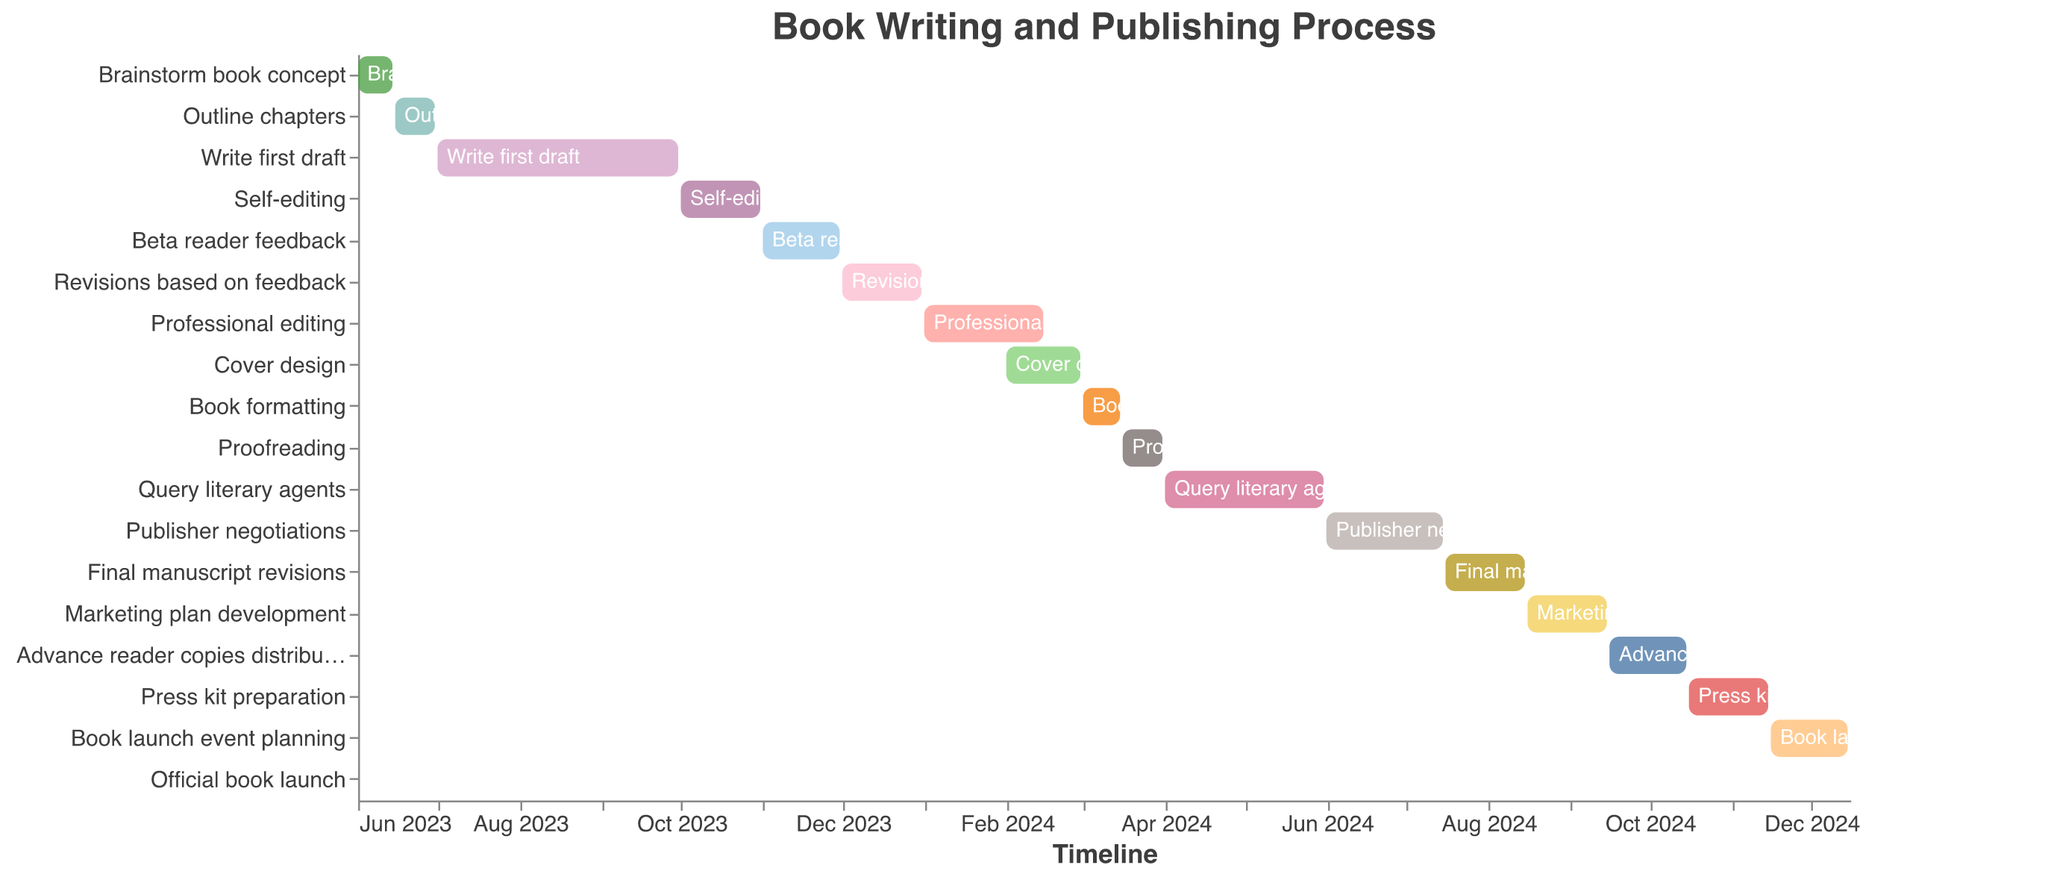What's the title of the plot? The title is prominently displayed at the top. It reads "Book Writing and Publishing Process".
Answer: Book Writing and Publishing Process Which task has the shortest duration? Referring to the Gantt Chart, the shortest bar indicates the "Official book launch" with a duration of 1 day.
Answer: Official book launch How many tasks are scheduled to start in 2024? By counting the tasks with start dates in 2024, we identify that there are nine tasks starting in 2024.
Answer: 9 Which task has the longest duration? The Gantt Chart's longest bar corresponds to "Write first draft", lasting 92 days.
Answer: Write first draft When does the "Cover design" task start and end? The Gantt Chart shows "Cover design" starts on 2024-02-01 and ends on 2024-02-29.
Answer: Starts: 2024-02-01, Ends: 2024-02-29 Which two tasks occur simultaneously for at least part of their duration? "Professional editing" and "Cover design" overlap from 2024-02-01 to 2024-02-15 as shown by their concurrent bars.
Answer: Professional editing and Cover design What is the combined duration of "Self-editing" and "Beta reader feedback"? The duration of "Self-editing" is 31 days and "Beta reader feedback" is 30 days. Combined, their duration is 31 + 30 = 61 days.
Answer: 61 days Do any tasks span across multiple months? Yes, several tasks span across multiple months, for instance, "Write first draft" spans from 2023-07-01 to 2023-09-30.
Answer: Yes Which tasks are planned to occur in December 2024? According to the Gantt Chart, "Book launch event planning" (ends on 2024-12-15) and "Official book launch" (on 2024-12-16) occur in December 2024.
Answer: Book launch event planning and Official book launch What's the gap between the end of "Query literary agents" and the start of "Final manuscript revisions"? "Query literary agents" ends on 2024-05-31 and "Final manuscript revisions" starts on 2024-07-16, thus the gap is from 2024-06-01 to 2024-07-15, which is 45 days.
Answer: 45 days 